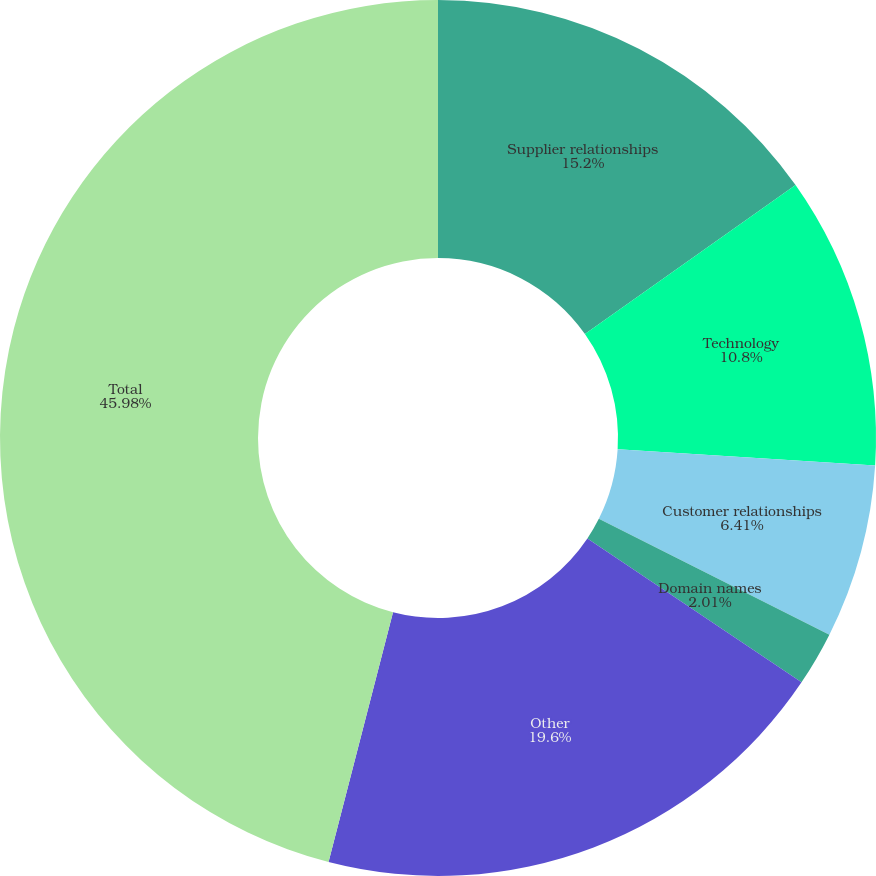Convert chart to OTSL. <chart><loc_0><loc_0><loc_500><loc_500><pie_chart><fcel>Supplier relationships<fcel>Technology<fcel>Customer relationships<fcel>Domain names<fcel>Other<fcel>Total<nl><fcel>15.2%<fcel>10.8%<fcel>6.41%<fcel>2.01%<fcel>19.6%<fcel>45.98%<nl></chart> 